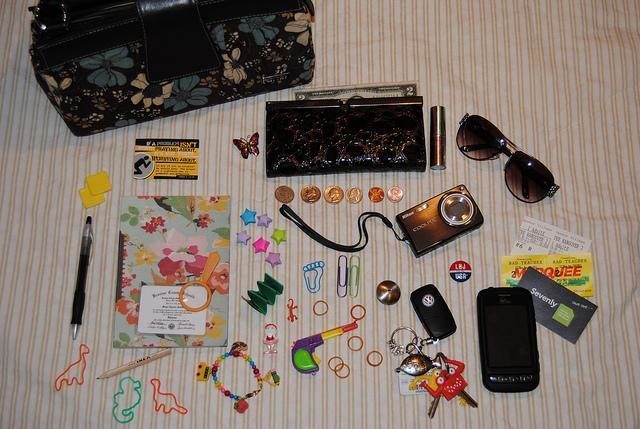How many sunglasses?
Give a very brief answer. 1. How many kites in the sky?
Give a very brief answer. 0. 